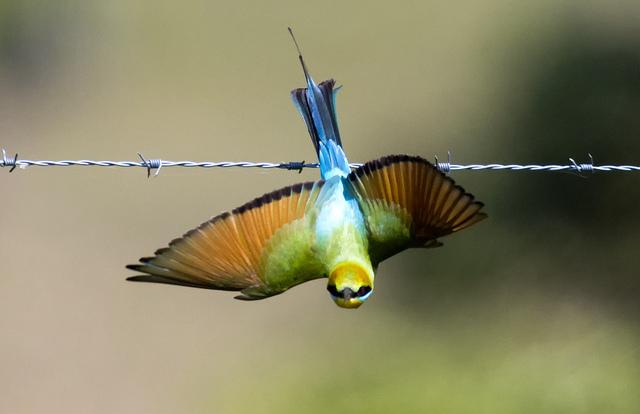Is the bird flying?
Keep it brief. No. What type of wire is the bird on?
Keep it brief. Barbed. What color is the bird's head?
Give a very brief answer. Yellow. 